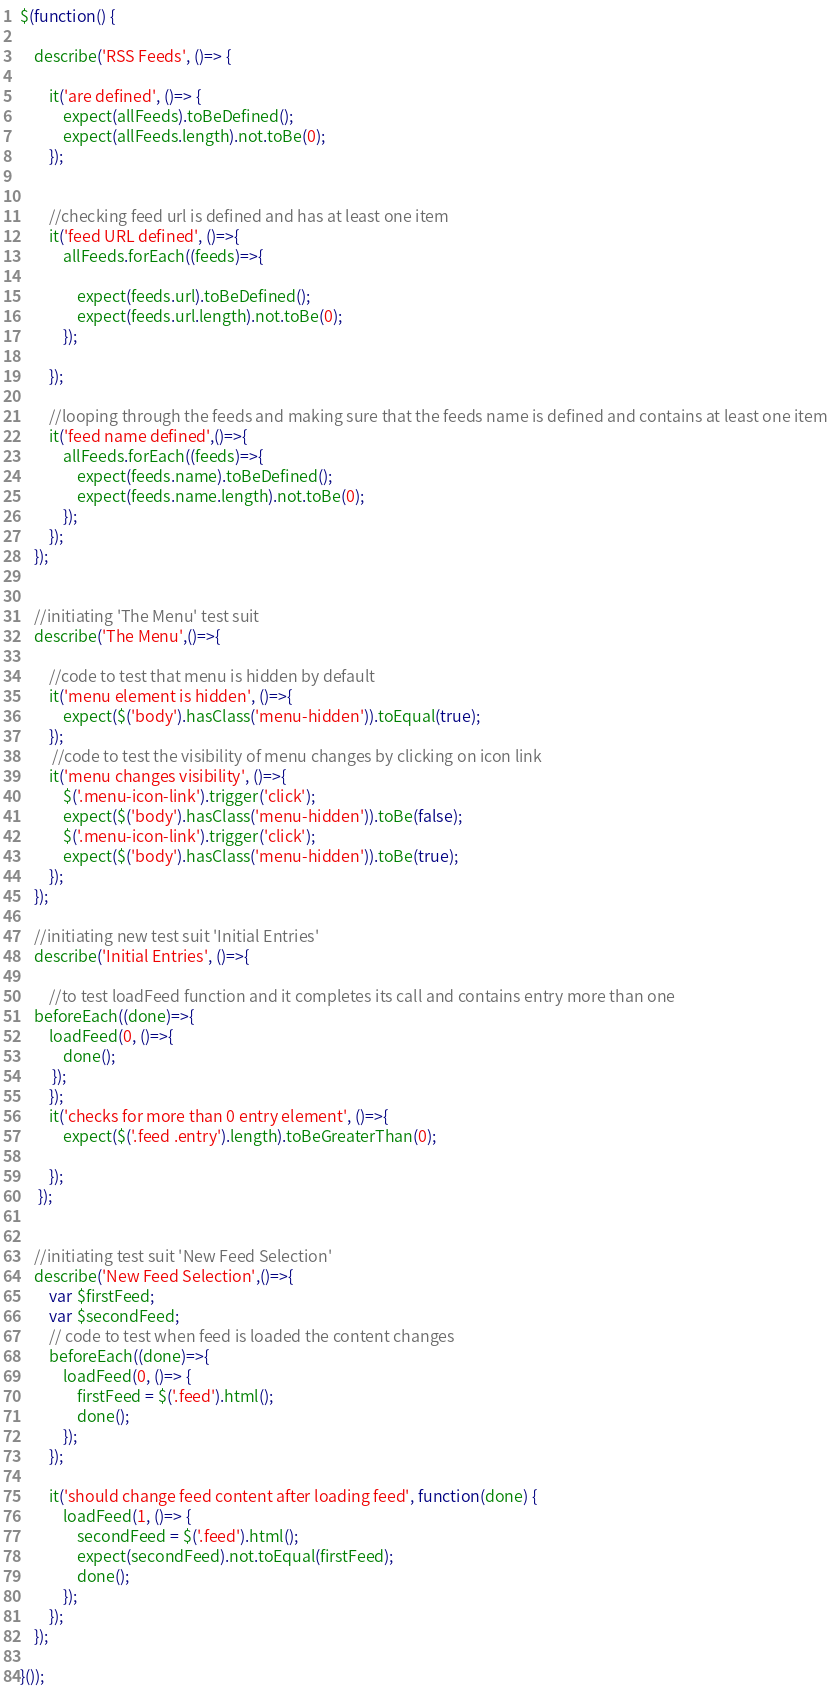Convert code to text. <code><loc_0><loc_0><loc_500><loc_500><_JavaScript_>
$(function() {
    
    describe('RSS Feeds', ()=> {
        
        it('are defined', ()=> {
            expect(allFeeds).toBeDefined();
            expect(allFeeds.length).not.toBe(0);
        });


        //checking feed url is defined and has at least one item
        it('feed URL defined', ()=>{
            allFeeds.forEach((feeds)=>{ 
                
                expect(feeds.url).toBeDefined();
                expect(feeds.url.length).not.toBe(0);
            });
           
        });

        //looping through the feeds and making sure that the feeds name is defined and contains at least one item
        it('feed name defined',()=>{
            allFeeds.forEach((feeds)=>{
                expect(feeds.name).toBeDefined();
                expect(feeds.name.length).not.toBe(0);
            });
        });
    });


    //initiating 'The Menu' test suit
    describe('The Menu',()=>{
        
        //code to test that menu is hidden by default
        it('menu element is hidden', ()=>{
            expect($('body').hasClass('menu-hidden')).toEqual(true);
        });
         //code to test the visibility of menu changes by clicking on icon link
        it('menu changes visibility', ()=>{
            $('.menu-icon-link').trigger('click');
            expect($('body').hasClass('menu-hidden')).toBe(false);
            $('.menu-icon-link').trigger('click');
            expect($('body').hasClass('menu-hidden')).toBe(true);
        });
    });
    
    //initiating new test suit 'Initial Entries'
    describe('Initial Entries', ()=>{
        
        //to test loadFeed function and it completes its call and contains entry more than one
    beforeEach((done)=>{
        loadFeed(0, ()=>{
            done();
         });
        });
        it('checks for more than 0 entry element', ()=>{
            expect($('.feed .entry').length).toBeGreaterThan(0);
        
        });
     });
    
    
    //initiating test suit 'New Feed Selection'
    describe('New Feed Selection',()=>{
        var $firstFeed;
        var $secondFeed;
        // code to test when feed is loaded the content changes
        beforeEach((done)=>{
            loadFeed(0, ()=> {
                firstFeed = $('.feed').html();
                done();
            });
        });

        it('should change feed content after loading feed', function(done) {
            loadFeed(1, ()=> {
                secondFeed = $('.feed').html();
                expect(secondFeed).not.toEqual(firstFeed);
                done();
            });
        });
    });
        
}());
</code> 